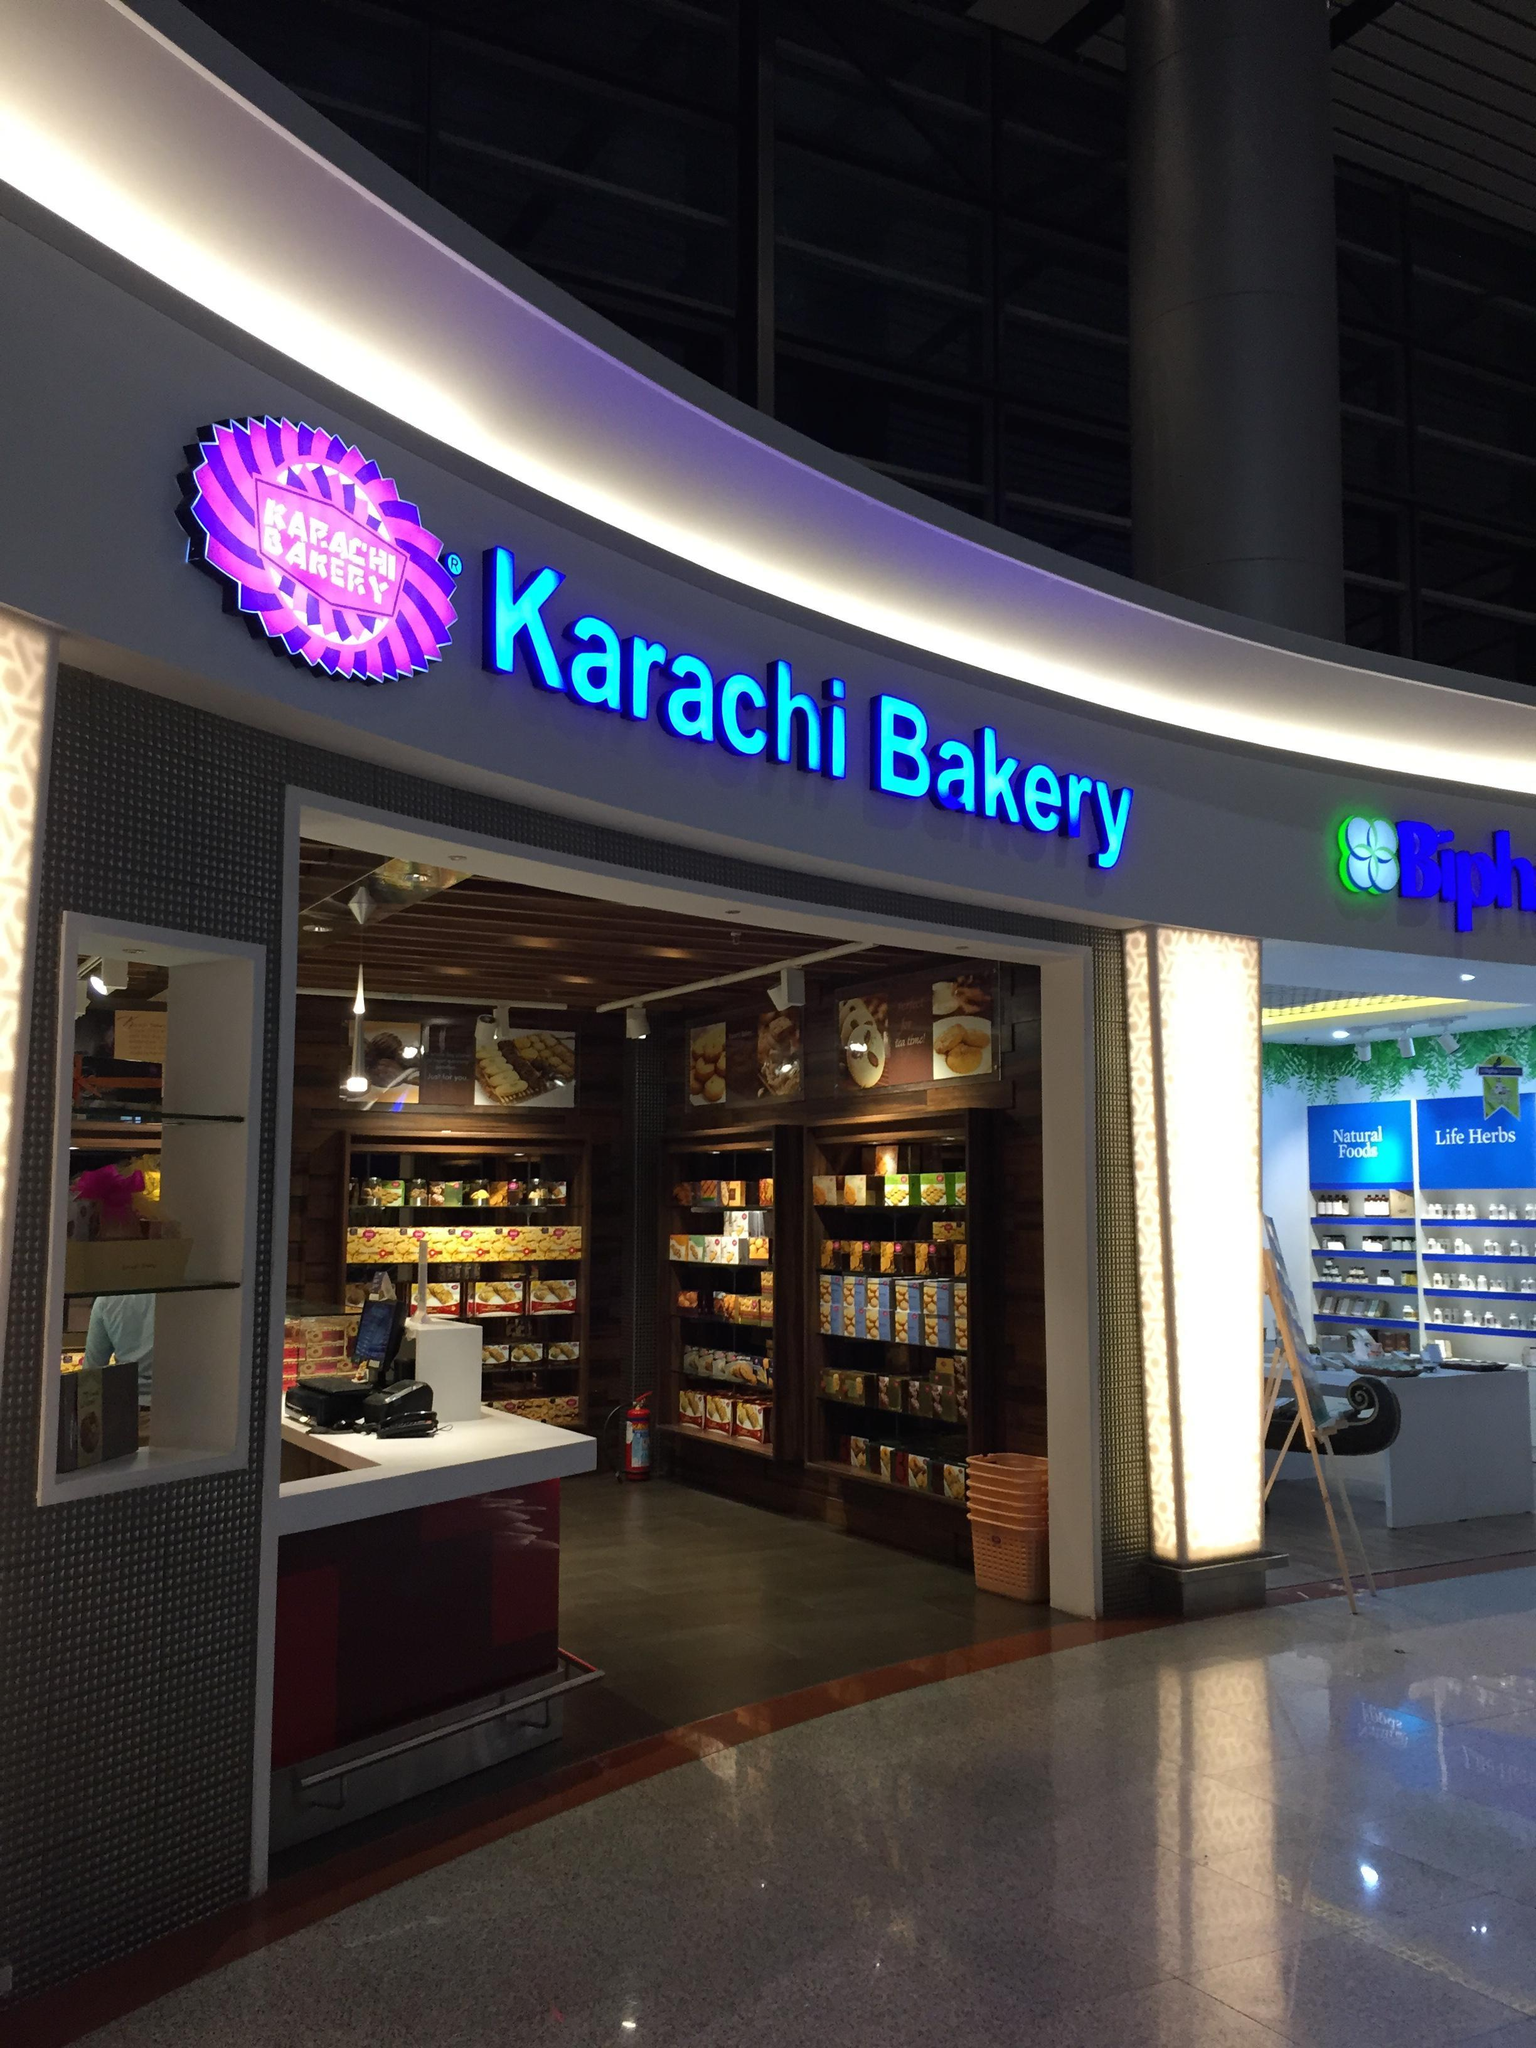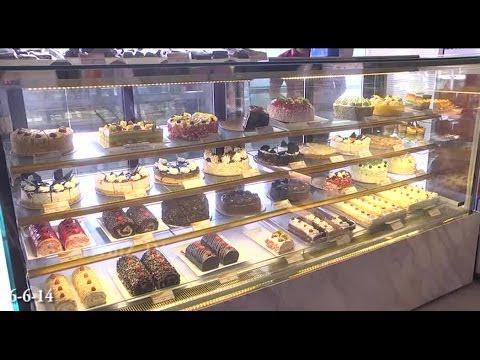The first image is the image on the left, the second image is the image on the right. Evaluate the accuracy of this statement regarding the images: "There is at least one person in front of a store in the right image.". Is it true? Answer yes or no. No. The first image is the image on the left, the second image is the image on the right. Examine the images to the left and right. Is the description "There is a four tier desert case that houses cholate desserts and breads." accurate? Answer yes or no. Yes. 